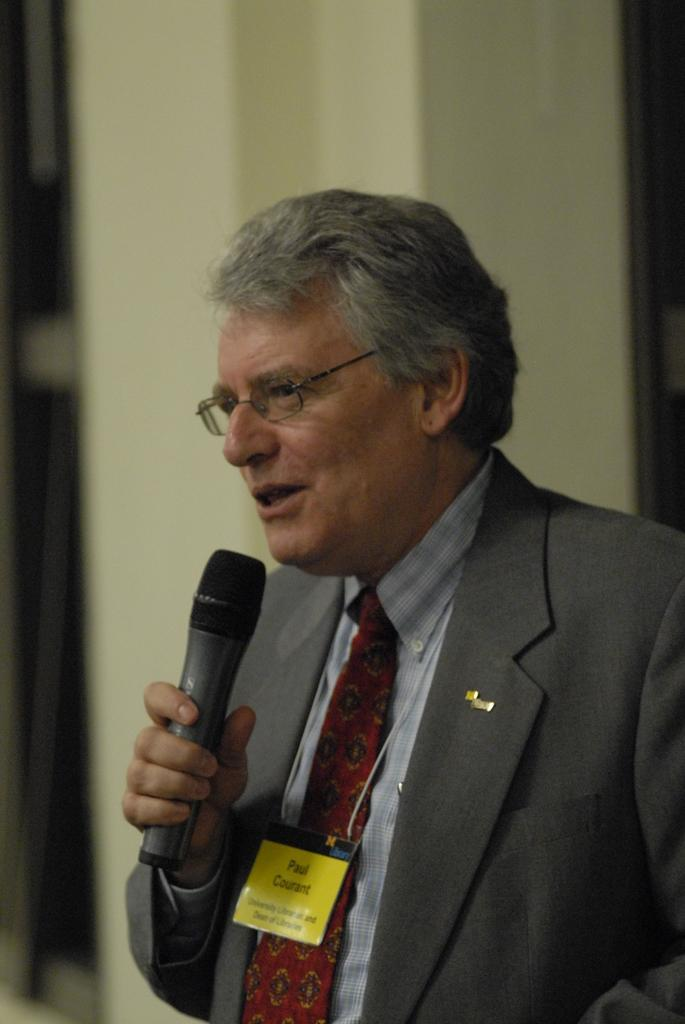What is the main subject of the image? There is a person in the image. What is the person holding in the image? The person is holding a microphone. What is the person doing in the image? The person is singing. How many screws can be seen on the person's clothing in the image? There are no screws visible on the person's clothing in the image. What type of expansion is taking place in the image? There is no expansion taking place in the image; it features a person singing with a microphone. 